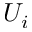<formula> <loc_0><loc_0><loc_500><loc_500>U _ { i }</formula> 